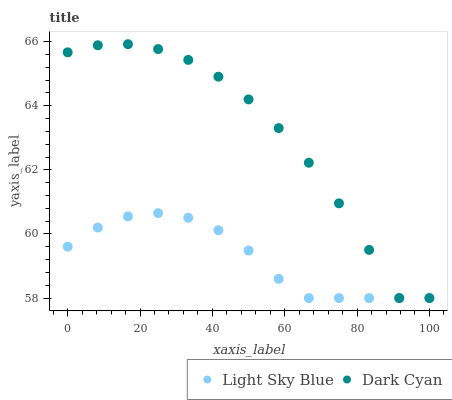Does Light Sky Blue have the minimum area under the curve?
Answer yes or no. Yes. Does Dark Cyan have the maximum area under the curve?
Answer yes or no. Yes. Does Light Sky Blue have the maximum area under the curve?
Answer yes or no. No. Is Light Sky Blue the smoothest?
Answer yes or no. Yes. Is Dark Cyan the roughest?
Answer yes or no. Yes. Is Light Sky Blue the roughest?
Answer yes or no. No. Does Dark Cyan have the lowest value?
Answer yes or no. Yes. Does Dark Cyan have the highest value?
Answer yes or no. Yes. Does Light Sky Blue have the highest value?
Answer yes or no. No. Does Light Sky Blue intersect Dark Cyan?
Answer yes or no. Yes. Is Light Sky Blue less than Dark Cyan?
Answer yes or no. No. Is Light Sky Blue greater than Dark Cyan?
Answer yes or no. No. 